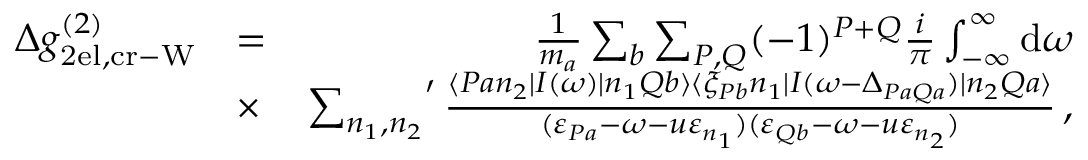<formula> <loc_0><loc_0><loc_500><loc_500>\begin{array} { r l r } { \Delta g _ { 2 e l , c r - W } ^ { ( 2 ) } } & { = } & { \frac { 1 } { m _ { a } } \sum _ { b } \sum _ { P , Q } ( - 1 ) ^ { P + Q } \frac { i } { \pi } \int _ { - \infty } ^ { \infty } d \omega } \\ & { \times } & { { \sum _ { n _ { 1 } , n _ { 2 } } } ^ { \prime } \, \frac { \langle P a n _ { 2 } | I ( \omega ) | n _ { 1 } Q b \rangle \langle \xi _ { P b } n _ { 1 } | I ( \omega - \Delta _ { P a Q a } ) | n _ { 2 } Q a \rangle } { ( \varepsilon _ { P a } - \omega - u \varepsilon _ { n _ { 1 } } ) ( \varepsilon _ { Q b } - \omega - u \varepsilon _ { n _ { 2 } } ) } \, , } \end{array}</formula> 